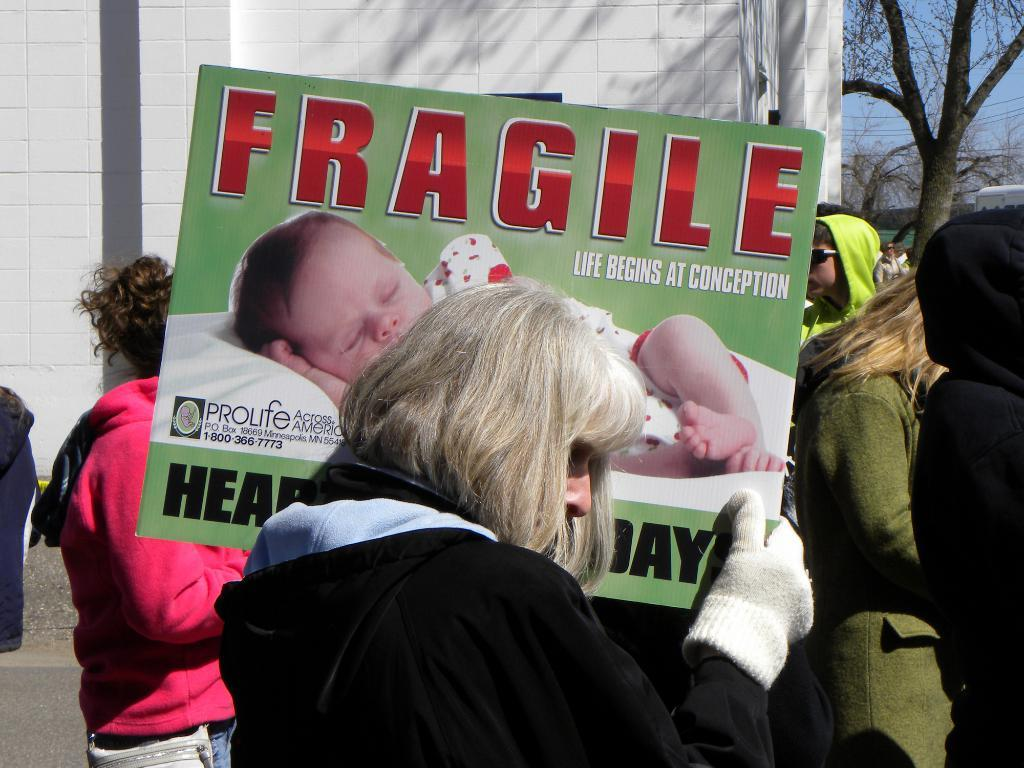What is the person holding in the image? The person is holding a board in the image. Can you describe the people in the image? There are people standing in the image. What can be seen in the background of the image? Trees, cables, a wall, and the sky are visible in the background of the image. What type of profit can be seen in the image? There is no mention of profit in the image; it features a person holding a board and people standing nearby. What season is depicted in the image? The image does not depict a specific season, as there are no seasonal cues present. 